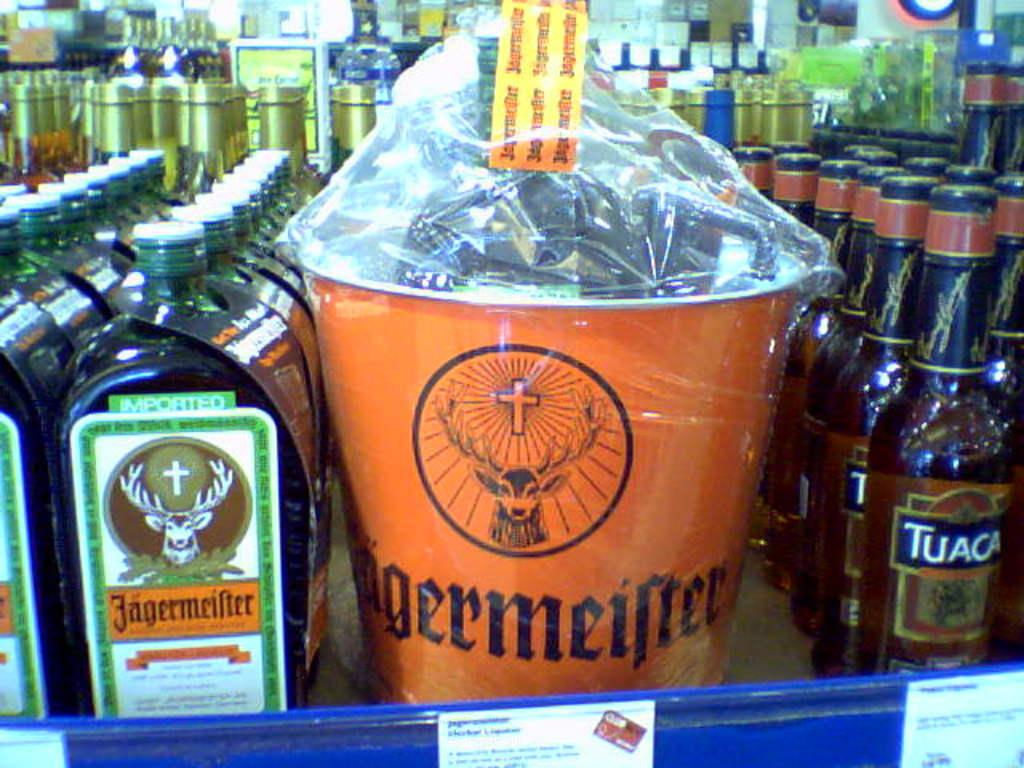<image>
Share a concise interpretation of the image provided. bottles of jagermeister next to an orange can labeled 'jagermeister' 